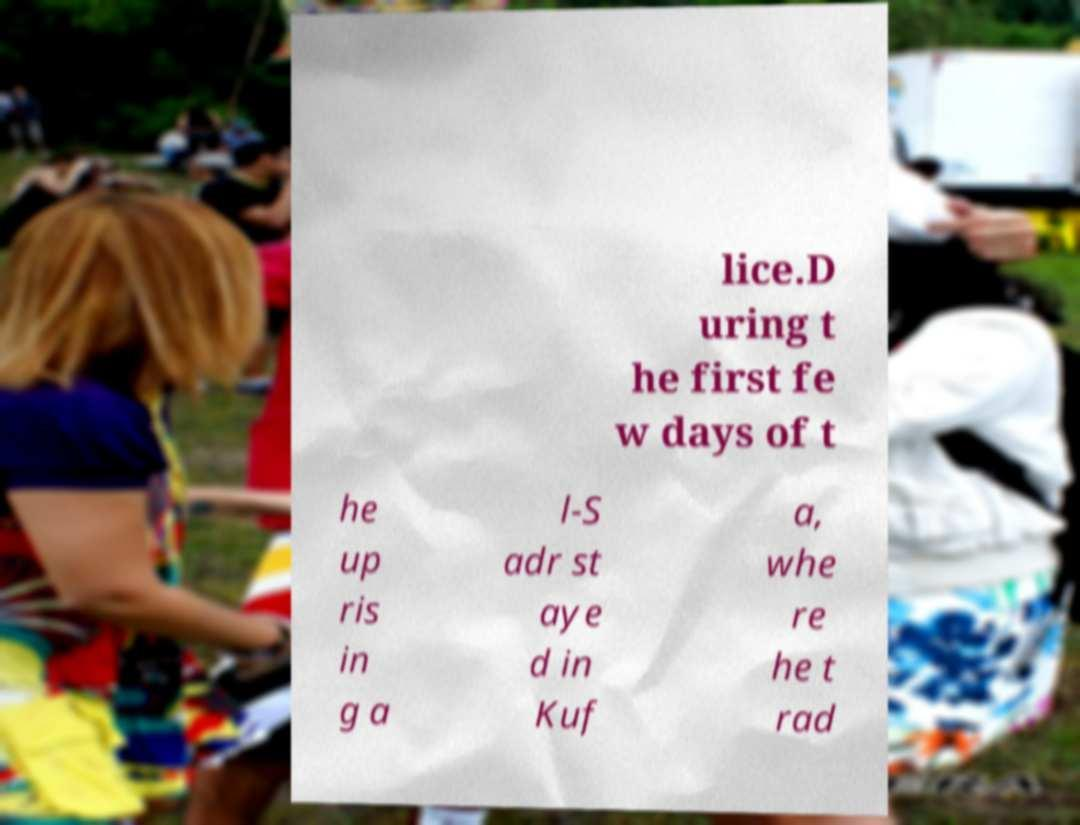Could you assist in decoding the text presented in this image and type it out clearly? lice.D uring t he first fe w days of t he up ris in g a l-S adr st aye d in Kuf a, whe re he t rad 